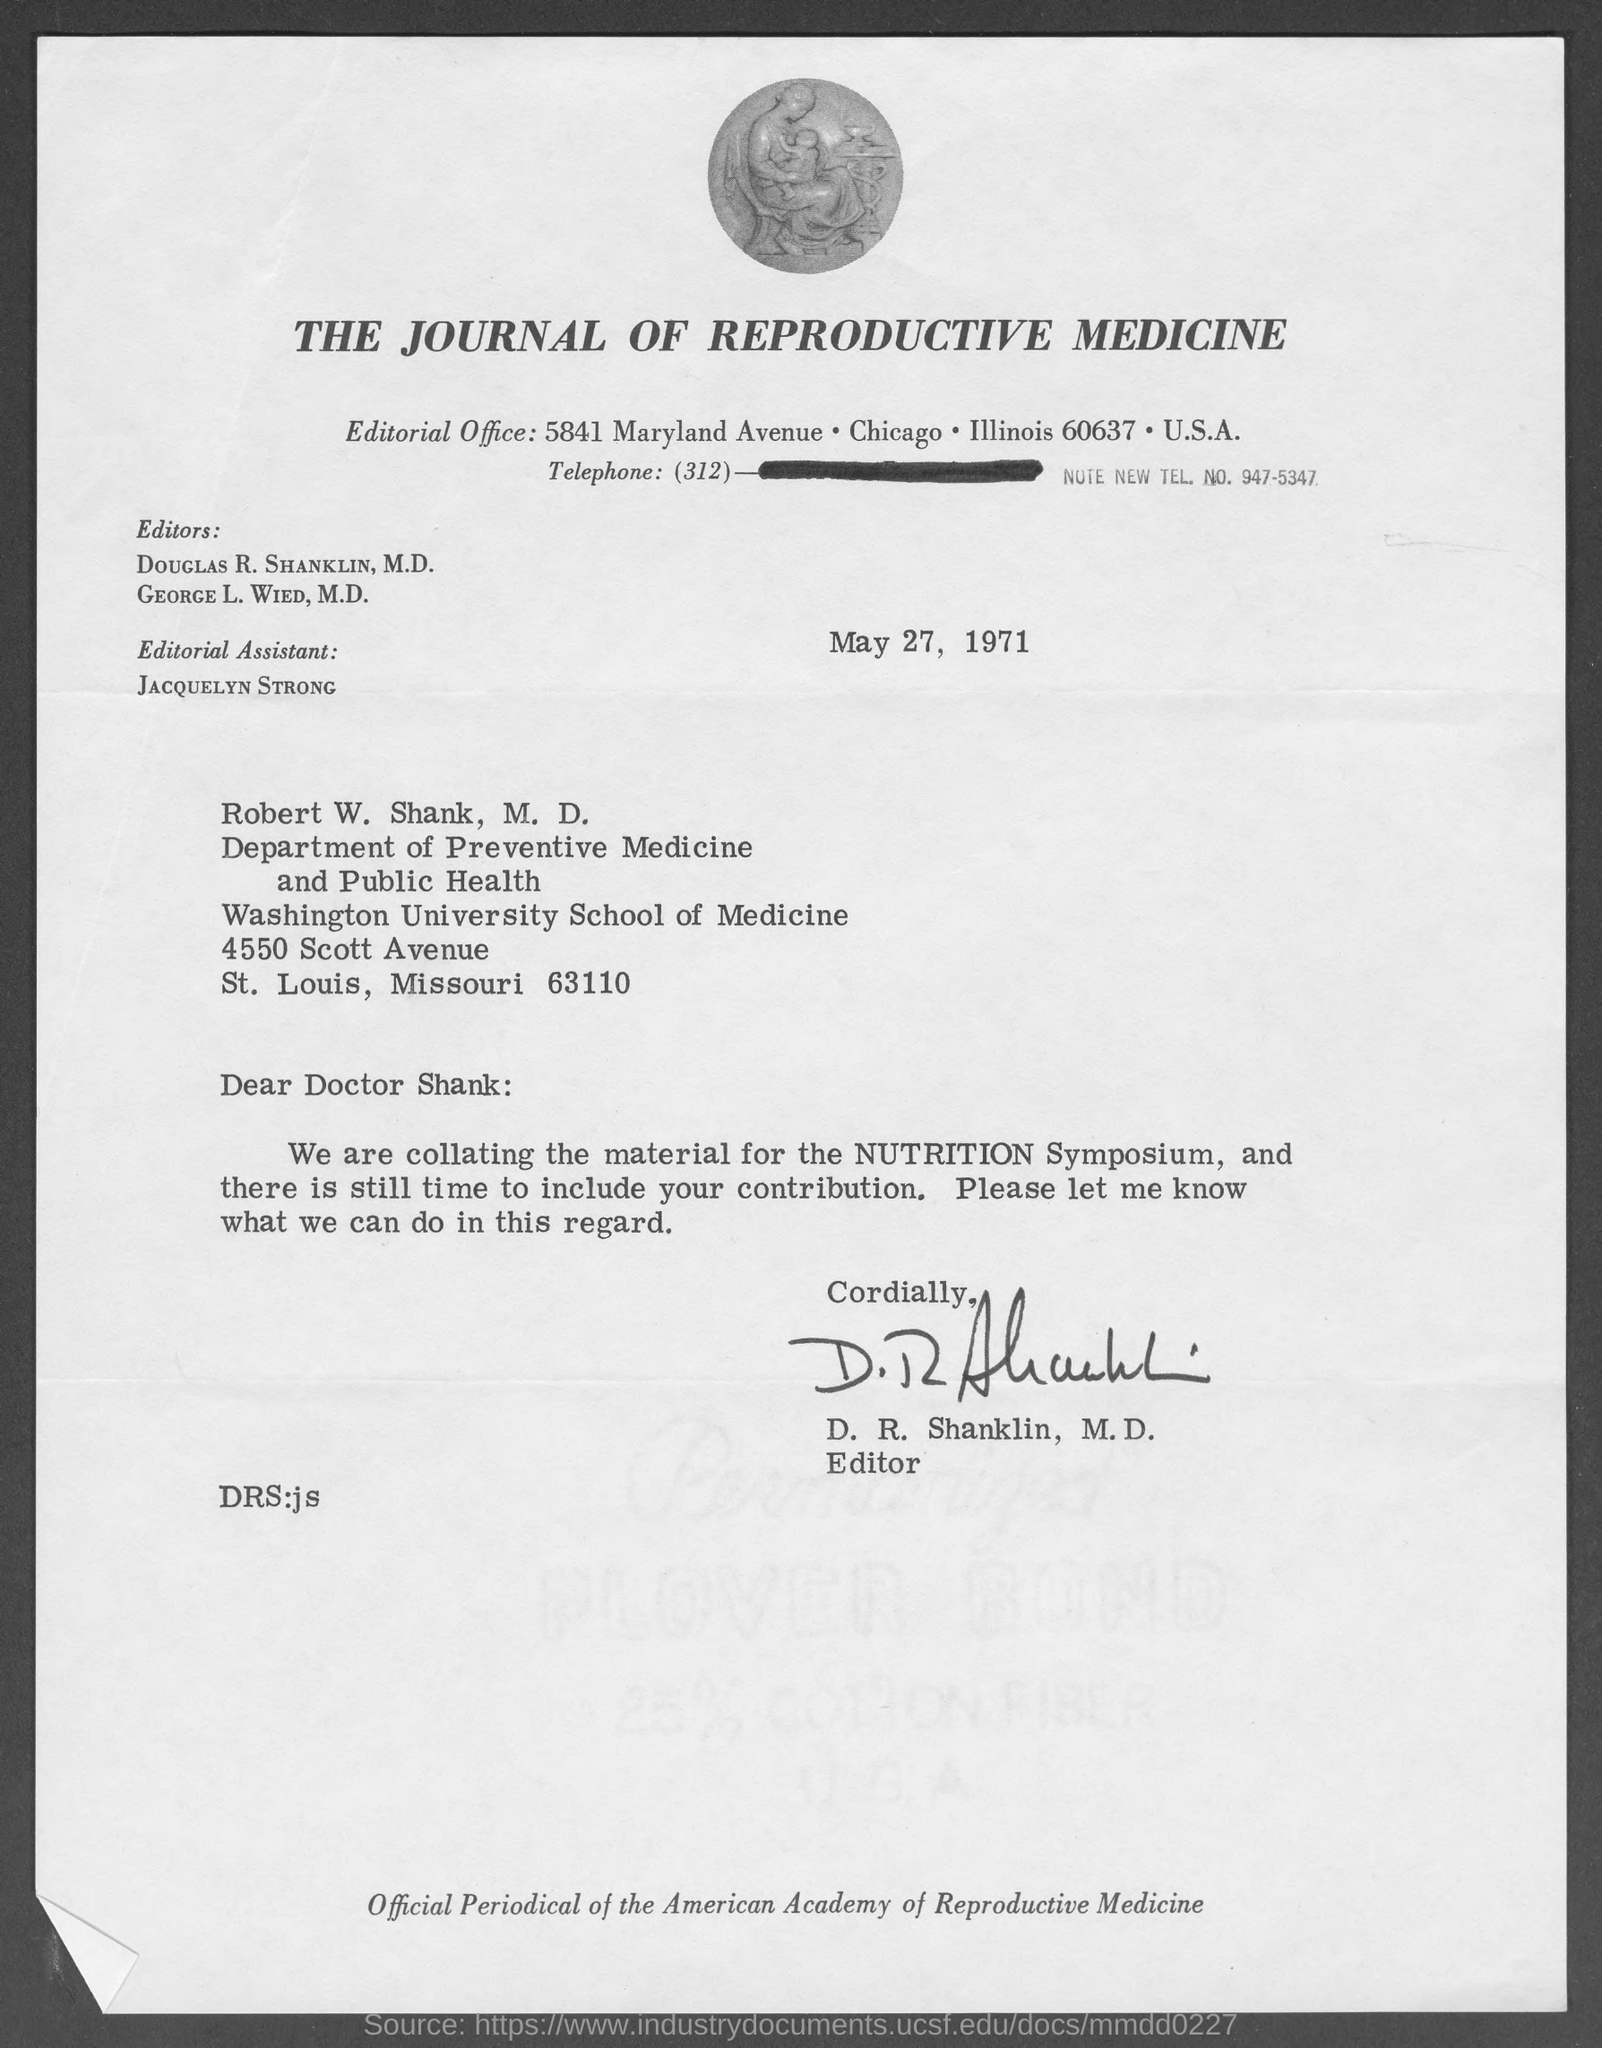Highlight a few significant elements in this photo. The document is titled "The Journal of Reproductive Medicine. The memorandum is from D. R. Shanklin, M.D. The memorandum was dated May 27, 1971. 